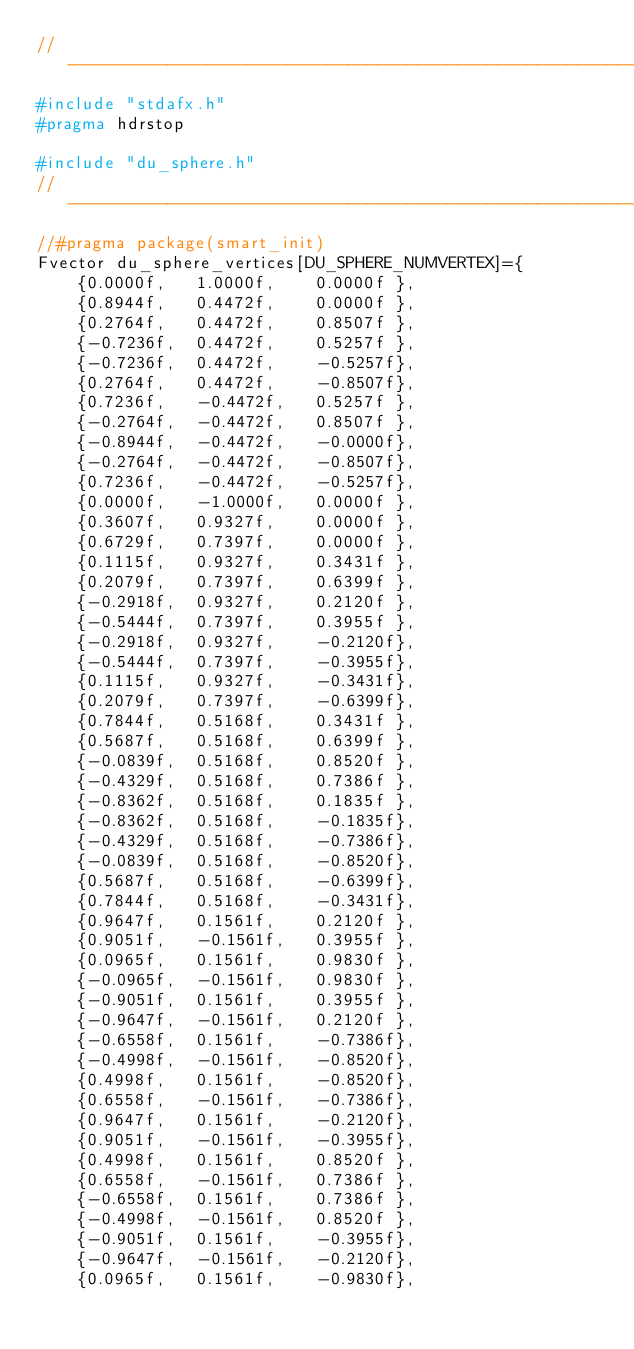Convert code to text. <code><loc_0><loc_0><loc_500><loc_500><_C++_>//---------------------------------------------------------------------------
#include "stdafx.h"
#pragma hdrstop

#include "du_sphere.h"
//---------------------------------------------------------------------------
//#pragma package(smart_init)
Fvector du_sphere_vertices[DU_SPHERE_NUMVERTEX]={
    {0.0000f,	1.0000f, 	0.0000f },
    {0.8944f,	0.4472f, 	0.0000f },
    {0.2764f,	0.4472f, 	0.8507f },
    {-0.7236f,	0.4472f, 	0.5257f },
    {-0.7236f,	0.4472f, 	-0.5257f},
    {0.2764f,	0.4472f, 	-0.8507f},
    {0.7236f,	-0.4472f,	0.5257f },
    {-0.2764f,	-0.4472f,	0.8507f },
    {-0.8944f,	-0.4472f,	-0.0000f},
    {-0.2764f,	-0.4472f,	-0.8507f},
    {0.7236f,	-0.4472f,	-0.5257f},
    {0.0000f,	-1.0000f,	0.0000f },
    {0.3607f,	0.9327f, 	0.0000f },
    {0.6729f,	0.7397f, 	0.0000f },
    {0.1115f,	0.9327f, 	0.3431f },
    {0.2079f,	0.7397f, 	0.6399f },
    {-0.2918f,	0.9327f, 	0.2120f },
    {-0.5444f,	0.7397f, 	0.3955f },
    {-0.2918f,	0.9327f, 	-0.2120f},
    {-0.5444f,	0.7397f, 	-0.3955f},
    {0.1115f,	0.9327f, 	-0.3431f},
    {0.2079f,	0.7397f, 	-0.6399f},
    {0.7844f,	0.5168f, 	0.3431f },
    {0.5687f,	0.5168f, 	0.6399f },
    {-0.0839f,	0.5168f, 	0.8520f },
    {-0.4329f,	0.5168f, 	0.7386f },
    {-0.8362f,	0.5168f, 	0.1835f },
    {-0.8362f,	0.5168f, 	-0.1835f},
    {-0.4329f,	0.5168f, 	-0.7386f},
    {-0.0839f,	0.5168f, 	-0.8520f},
    {0.5687f,	0.5168f, 	-0.6399f},
    {0.7844f,	0.5168f, 	-0.3431f},
    {0.9647f,	0.1561f, 	0.2120f },
    {0.9051f,	-0.1561f,	0.3955f },
    {0.0965f,	0.1561f, 	0.9830f },
    {-0.0965f,	-0.1561f,	0.9830f },
    {-0.9051f,	0.1561f, 	0.3955f },
    {-0.9647f,	-0.1561f,	0.2120f },
    {-0.6558f,	0.1561f, 	-0.7386f},
    {-0.4998f,	-0.1561f,	-0.8520f},
    {0.4998f,	0.1561f, 	-0.8520f},
    {0.6558f,	-0.1561f,	-0.7386f},
    {0.9647f,	0.1561f, 	-0.2120f},
    {0.9051f,	-0.1561f,	-0.3955f},
    {0.4998f,	0.1561f, 	0.8520f },
    {0.6558f,	-0.1561f,	0.7386f },
    {-0.6558f,	0.1561f, 	0.7386f },
    {-0.4998f,	-0.1561f,	0.8520f },
    {-0.9051f,	0.1561f, 	-0.3955f},
    {-0.9647f,	-0.1561f,	-0.2120f},
    {0.0965f,	0.1561f, 	-0.9830f},</code> 